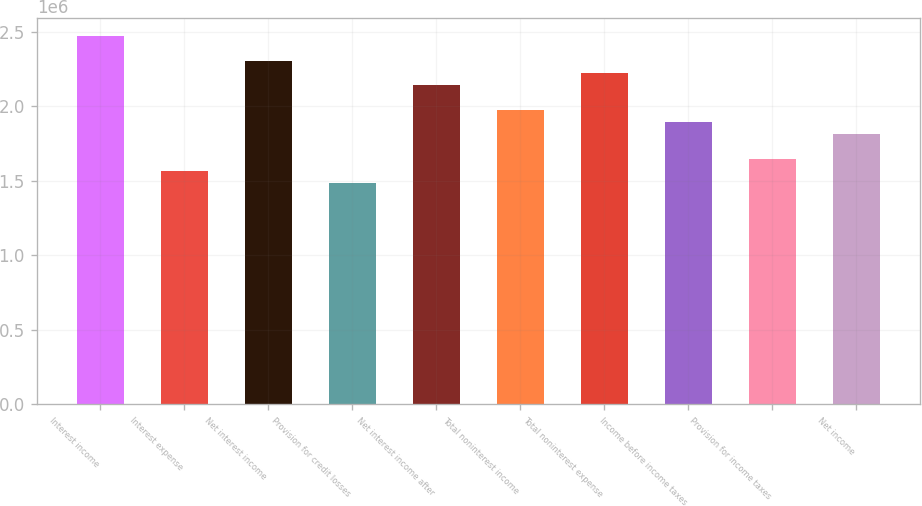Convert chart. <chart><loc_0><loc_0><loc_500><loc_500><bar_chart><fcel>Interest income<fcel>Interest expense<fcel>Net interest income<fcel>Provision for credit losses<fcel>Net interest income after<fcel>Total noninterest income<fcel>Total noninterest expense<fcel>Income before income taxes<fcel>Provision for income taxes<fcel>Net income<nl><fcel>2.47143e+06<fcel>1.56524e+06<fcel>2.30666e+06<fcel>1.48286e+06<fcel>2.1419e+06<fcel>1.97714e+06<fcel>2.22428e+06<fcel>1.89476e+06<fcel>1.64762e+06<fcel>1.81238e+06<nl></chart> 